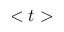<formula> <loc_0><loc_0><loc_500><loc_500>< t ></formula> 